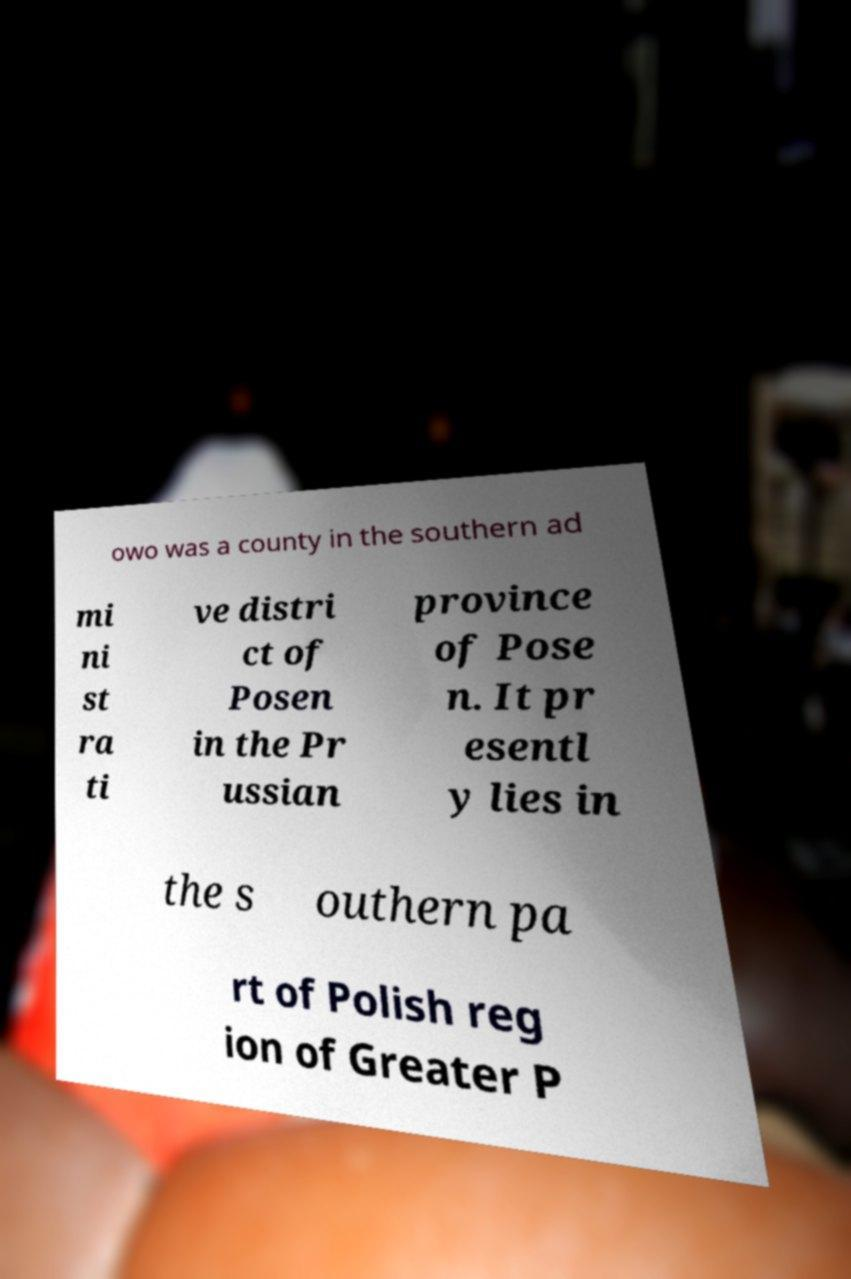Can you accurately transcribe the text from the provided image for me? owo was a county in the southern ad mi ni st ra ti ve distri ct of Posen in the Pr ussian province of Pose n. It pr esentl y lies in the s outhern pa rt of Polish reg ion of Greater P 